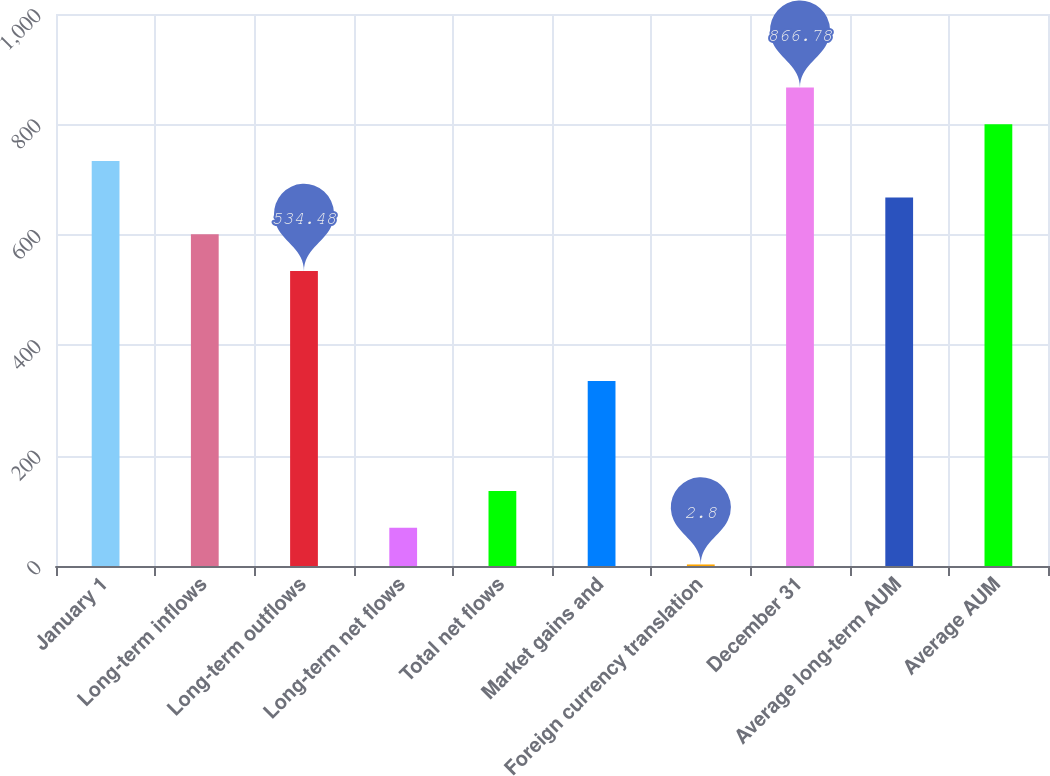<chart> <loc_0><loc_0><loc_500><loc_500><bar_chart><fcel>January 1<fcel>Long-term inflows<fcel>Long-term outflows<fcel>Long-term net flows<fcel>Total net flows<fcel>Market gains and<fcel>Foreign currency translation<fcel>December 31<fcel>Average long-term AUM<fcel>Average AUM<nl><fcel>733.86<fcel>600.94<fcel>534.48<fcel>69.26<fcel>135.72<fcel>335.1<fcel>2.8<fcel>866.78<fcel>667.4<fcel>800.32<nl></chart> 